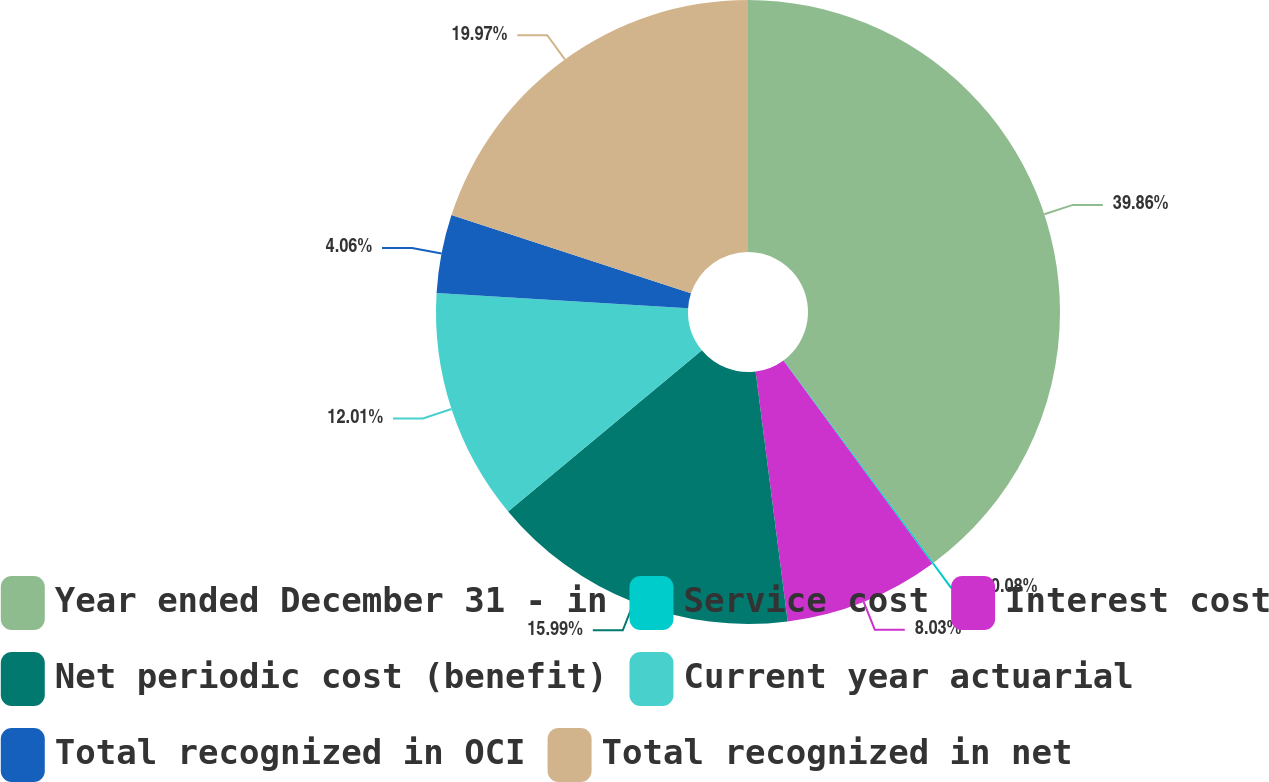Convert chart. <chart><loc_0><loc_0><loc_500><loc_500><pie_chart><fcel>Year ended December 31 - in<fcel>Service cost<fcel>Interest cost<fcel>Net periodic cost (benefit)<fcel>Current year actuarial<fcel>Total recognized in OCI<fcel>Total recognized in net<nl><fcel>39.86%<fcel>0.08%<fcel>8.03%<fcel>15.99%<fcel>12.01%<fcel>4.06%<fcel>19.97%<nl></chart> 